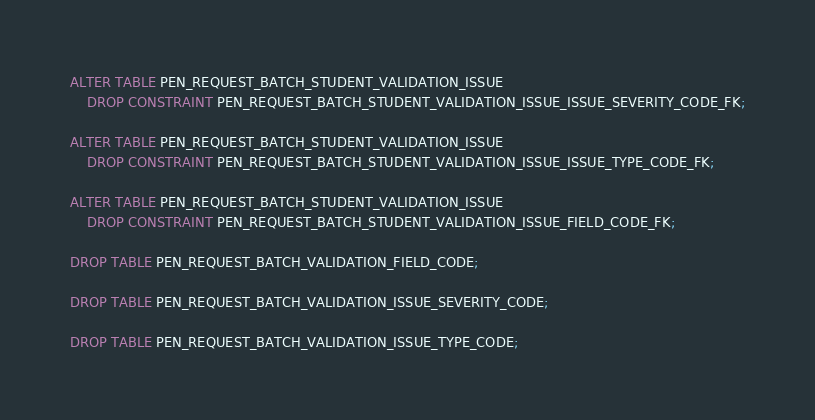Convert code to text. <code><loc_0><loc_0><loc_500><loc_500><_SQL_>ALTER TABLE PEN_REQUEST_BATCH_STUDENT_VALIDATION_ISSUE
    DROP CONSTRAINT PEN_REQUEST_BATCH_STUDENT_VALIDATION_ISSUE_ISSUE_SEVERITY_CODE_FK;

ALTER TABLE PEN_REQUEST_BATCH_STUDENT_VALIDATION_ISSUE
    DROP CONSTRAINT PEN_REQUEST_BATCH_STUDENT_VALIDATION_ISSUE_ISSUE_TYPE_CODE_FK;

ALTER TABLE PEN_REQUEST_BATCH_STUDENT_VALIDATION_ISSUE
    DROP CONSTRAINT PEN_REQUEST_BATCH_STUDENT_VALIDATION_ISSUE_FIELD_CODE_FK;

DROP TABLE PEN_REQUEST_BATCH_VALIDATION_FIELD_CODE;

DROP TABLE PEN_REQUEST_BATCH_VALIDATION_ISSUE_SEVERITY_CODE;

DROP TABLE PEN_REQUEST_BATCH_VALIDATION_ISSUE_TYPE_CODE;
</code> 